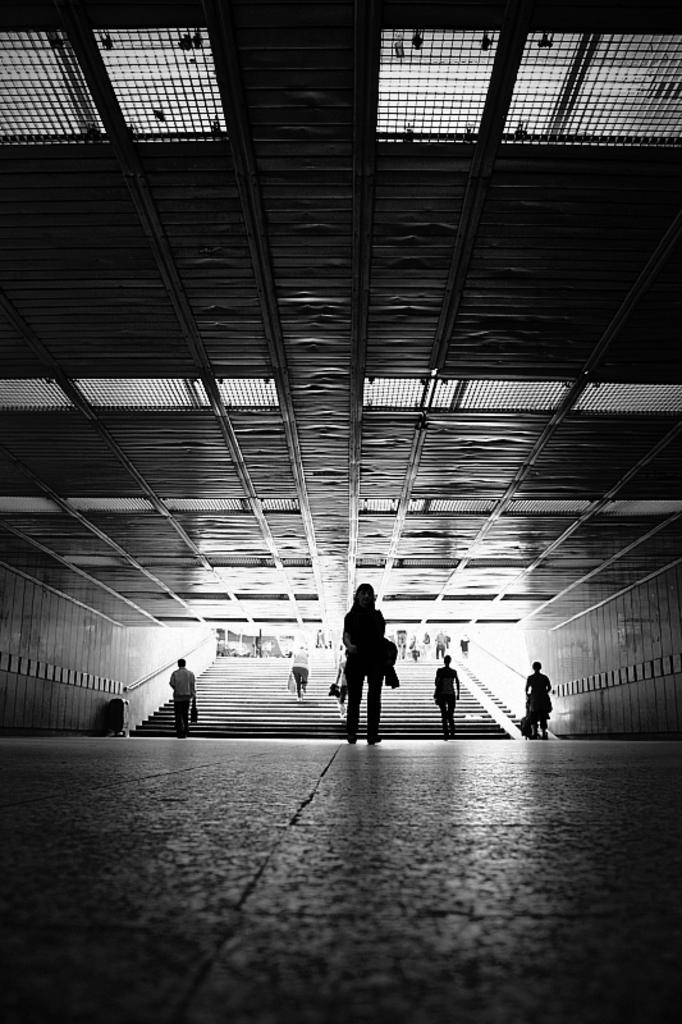What is the color scheme of the image? The image is black and white. What are the people in the image doing? The people are walking on a staircase in the center of the image. What is the surface beneath the people's feet? There is a floor visible in the image. What is above the people's heads in the image? There is a ceiling at the top of the image. What type of song can be heard playing in the background of the image? There is no sound or music present in the image, so it is not possible to determine what song might be playing. 